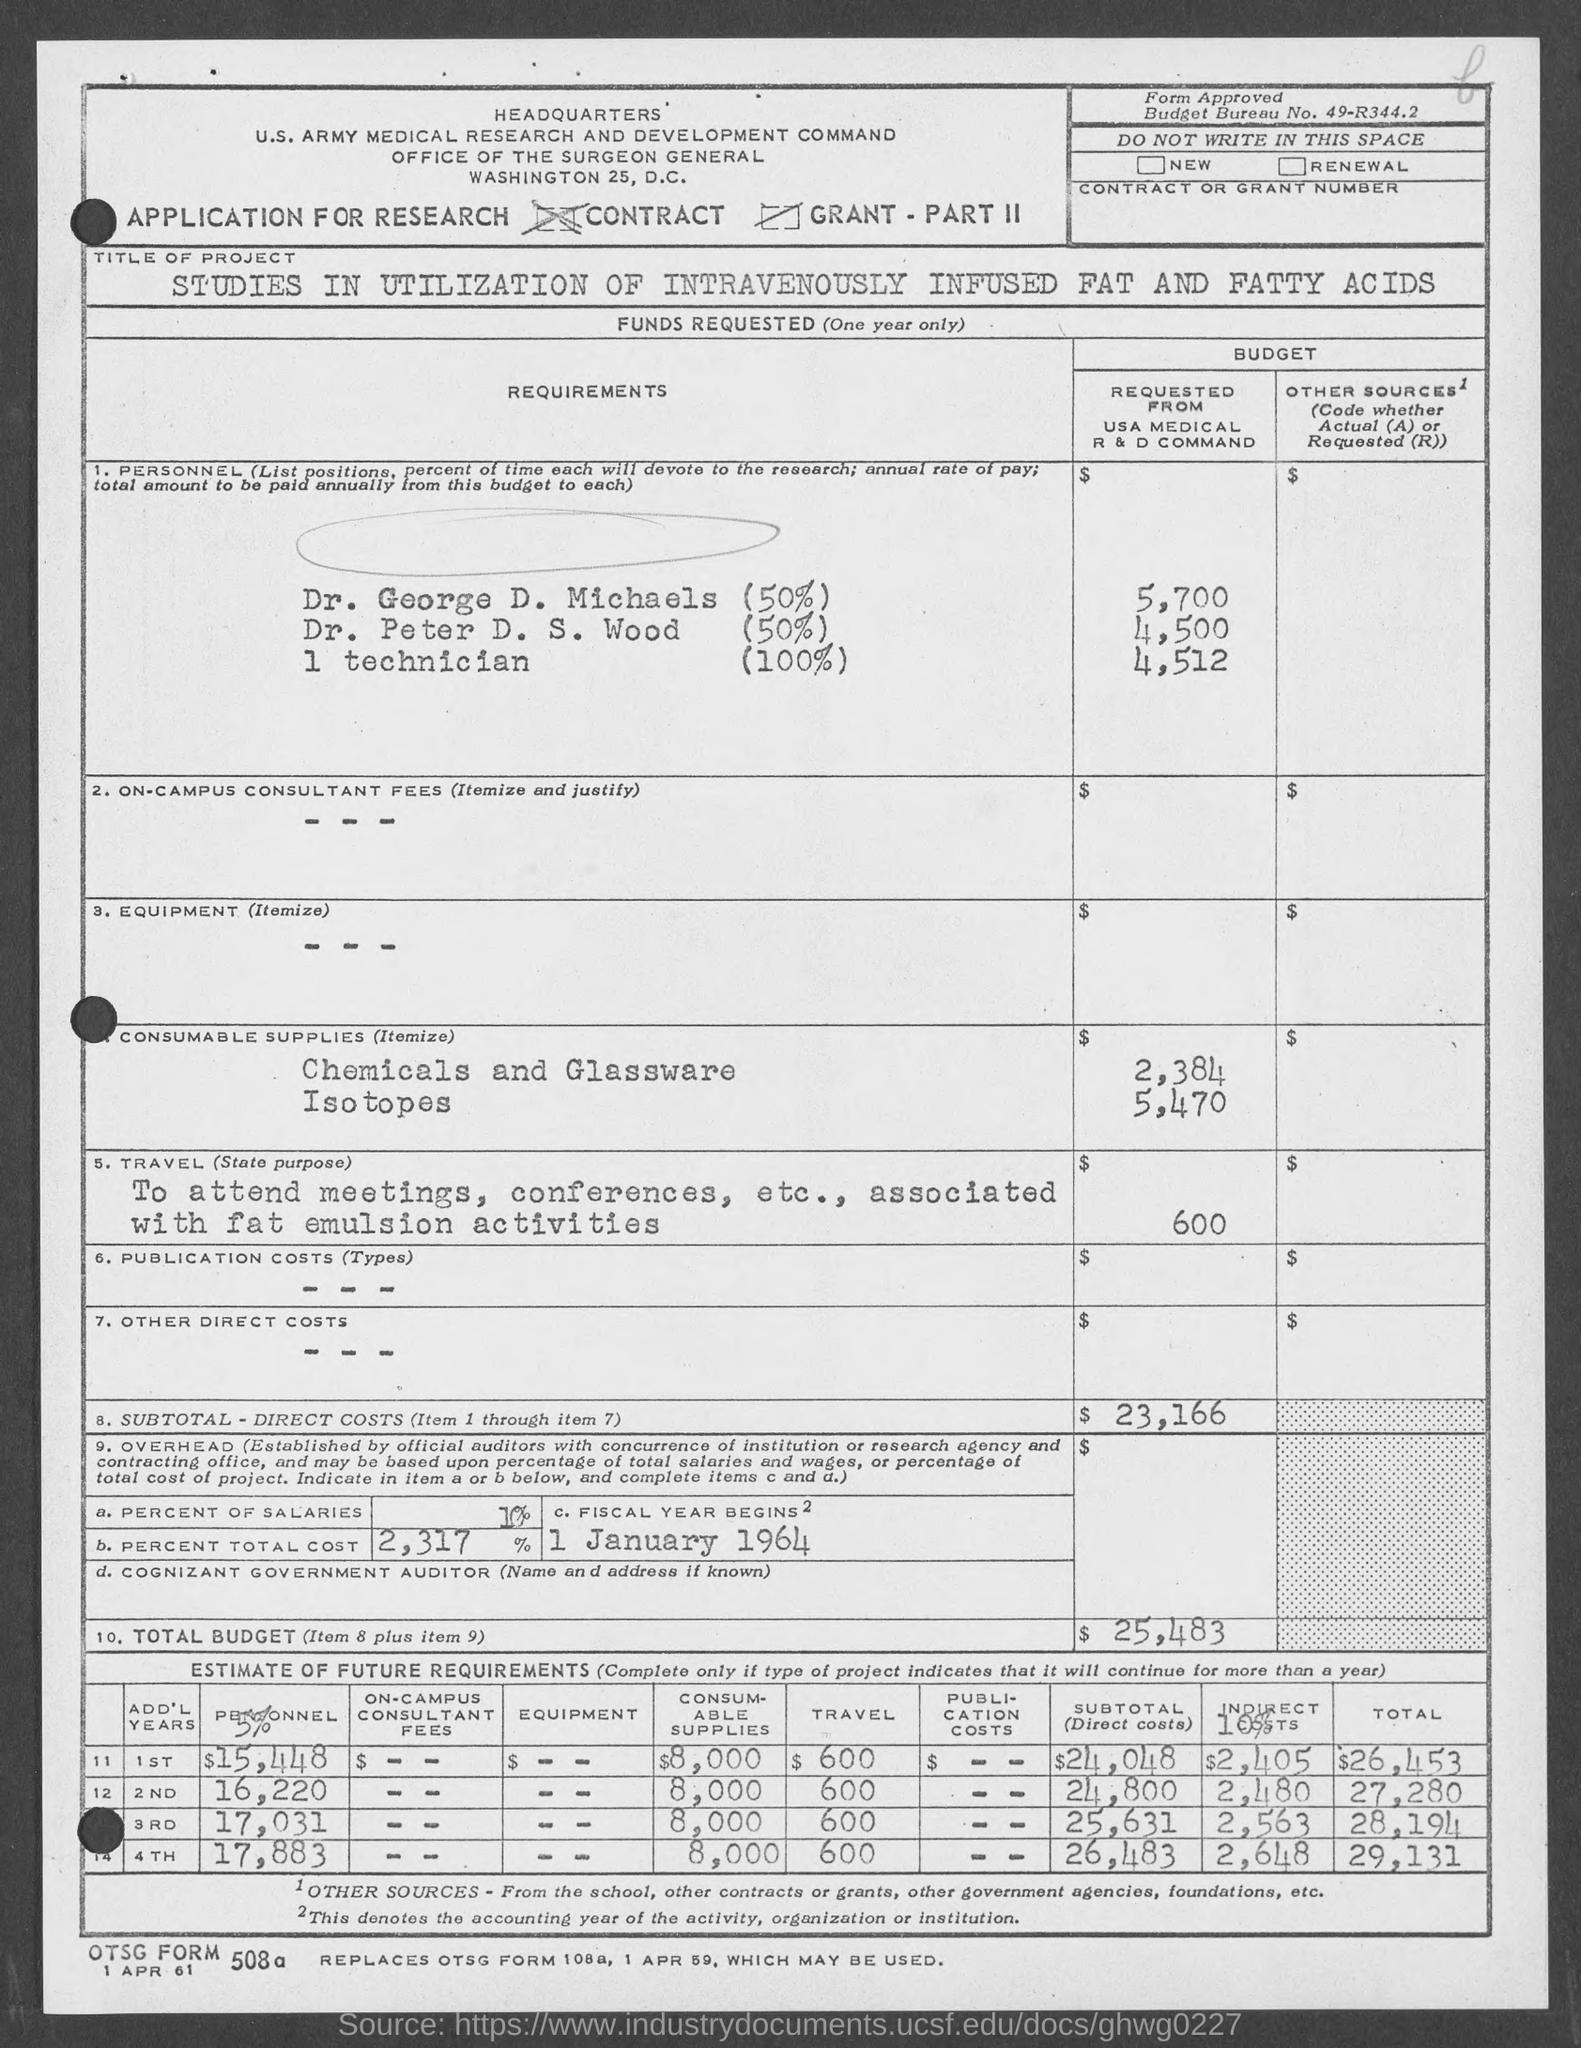What is the budget bureau no.?
Your response must be concise. 49-r344.2. When does the fiscal year begins ?
Offer a terse response. 1 january 1964. 